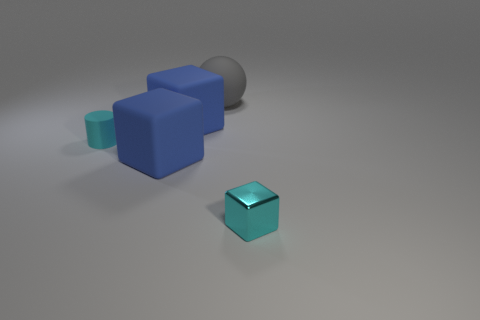Add 4 cyan metal objects. How many objects exist? 9 Subtract all cylinders. How many objects are left? 4 Subtract 1 spheres. How many spheres are left? 0 Subtract all tiny cyan metal cubes. How many cubes are left? 2 Subtract all cyan balls. Subtract all blue blocks. How many balls are left? 1 Subtract all blue cylinders. How many gray cubes are left? 0 Subtract all large objects. Subtract all small cyan shiny things. How many objects are left? 1 Add 5 rubber blocks. How many rubber blocks are left? 7 Add 1 big blue matte objects. How many big blue matte objects exist? 3 Subtract all cyan cubes. How many cubes are left? 2 